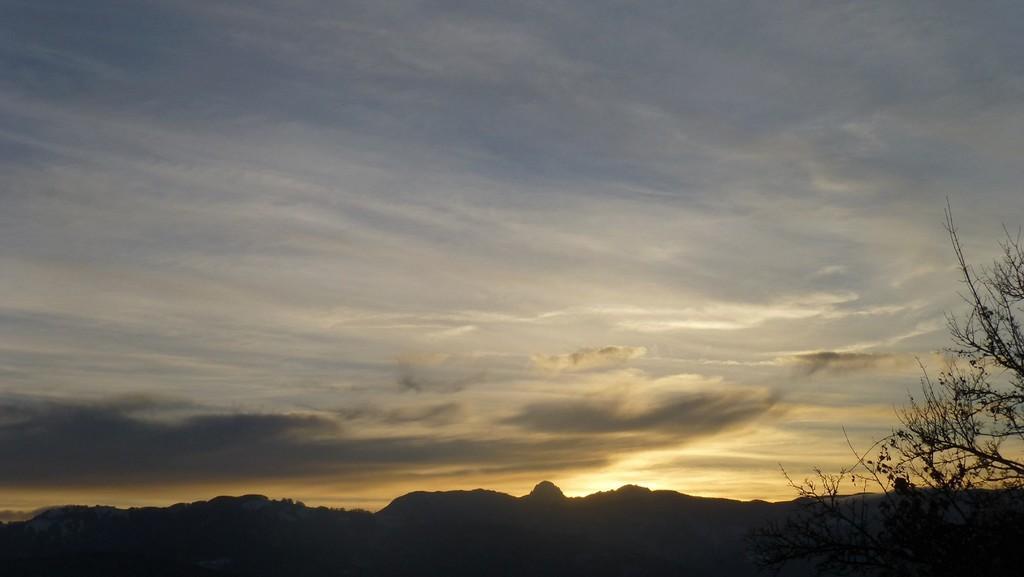Could you give a brief overview of what you see in this image? It seems like mountains as we can see at the bottom of this image and the sky is in the background. There is a tree in the bottom right corner of this image. 